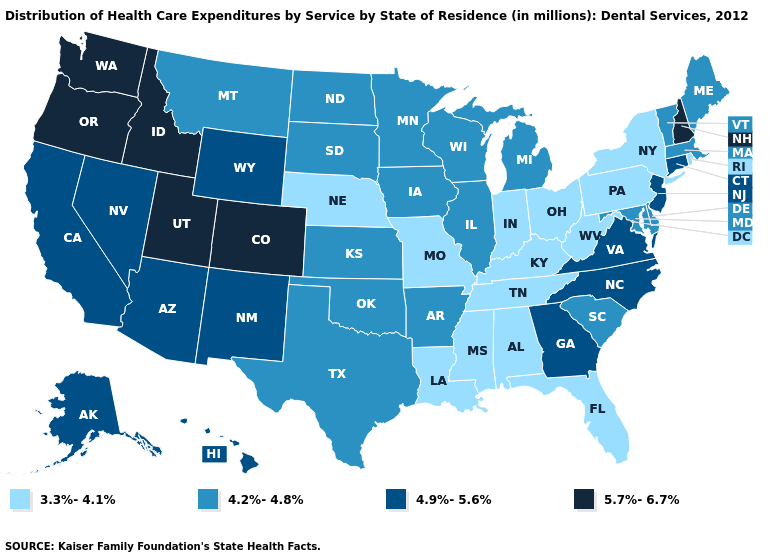What is the value of Indiana?
Answer briefly. 3.3%-4.1%. Does South Carolina have a lower value than South Dakota?
Concise answer only. No. What is the value of Rhode Island?
Answer briefly. 3.3%-4.1%. Among the states that border Arizona , which have the highest value?
Be succinct. Colorado, Utah. Among the states that border West Virginia , does Virginia have the highest value?
Answer briefly. Yes. Among the states that border Nevada , which have the lowest value?
Answer briefly. Arizona, California. Which states have the lowest value in the South?
Write a very short answer. Alabama, Florida, Kentucky, Louisiana, Mississippi, Tennessee, West Virginia. Name the states that have a value in the range 4.9%-5.6%?
Quick response, please. Alaska, Arizona, California, Connecticut, Georgia, Hawaii, Nevada, New Jersey, New Mexico, North Carolina, Virginia, Wyoming. Among the states that border Oklahoma , which have the lowest value?
Keep it brief. Missouri. Among the states that border Maryland , which have the highest value?
Give a very brief answer. Virginia. Is the legend a continuous bar?
Be succinct. No. Name the states that have a value in the range 4.9%-5.6%?
Write a very short answer. Alaska, Arizona, California, Connecticut, Georgia, Hawaii, Nevada, New Jersey, New Mexico, North Carolina, Virginia, Wyoming. Does Oregon have the highest value in the USA?
Short answer required. Yes. Among the states that border Indiana , does Ohio have the lowest value?
Give a very brief answer. Yes. Does the first symbol in the legend represent the smallest category?
Short answer required. Yes. 